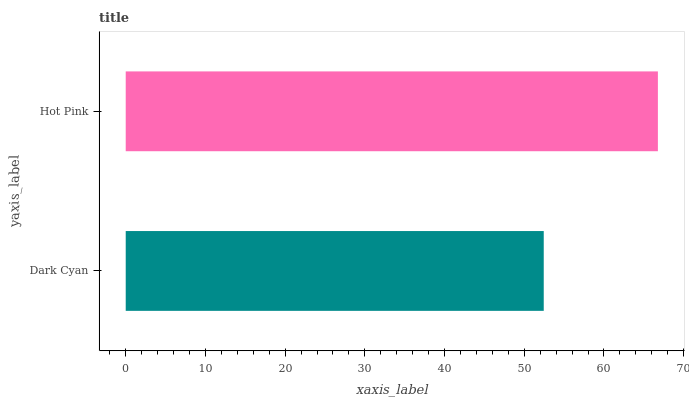Is Dark Cyan the minimum?
Answer yes or no. Yes. Is Hot Pink the maximum?
Answer yes or no. Yes. Is Hot Pink the minimum?
Answer yes or no. No. Is Hot Pink greater than Dark Cyan?
Answer yes or no. Yes. Is Dark Cyan less than Hot Pink?
Answer yes or no. Yes. Is Dark Cyan greater than Hot Pink?
Answer yes or no. No. Is Hot Pink less than Dark Cyan?
Answer yes or no. No. Is Hot Pink the high median?
Answer yes or no. Yes. Is Dark Cyan the low median?
Answer yes or no. Yes. Is Dark Cyan the high median?
Answer yes or no. No. Is Hot Pink the low median?
Answer yes or no. No. 